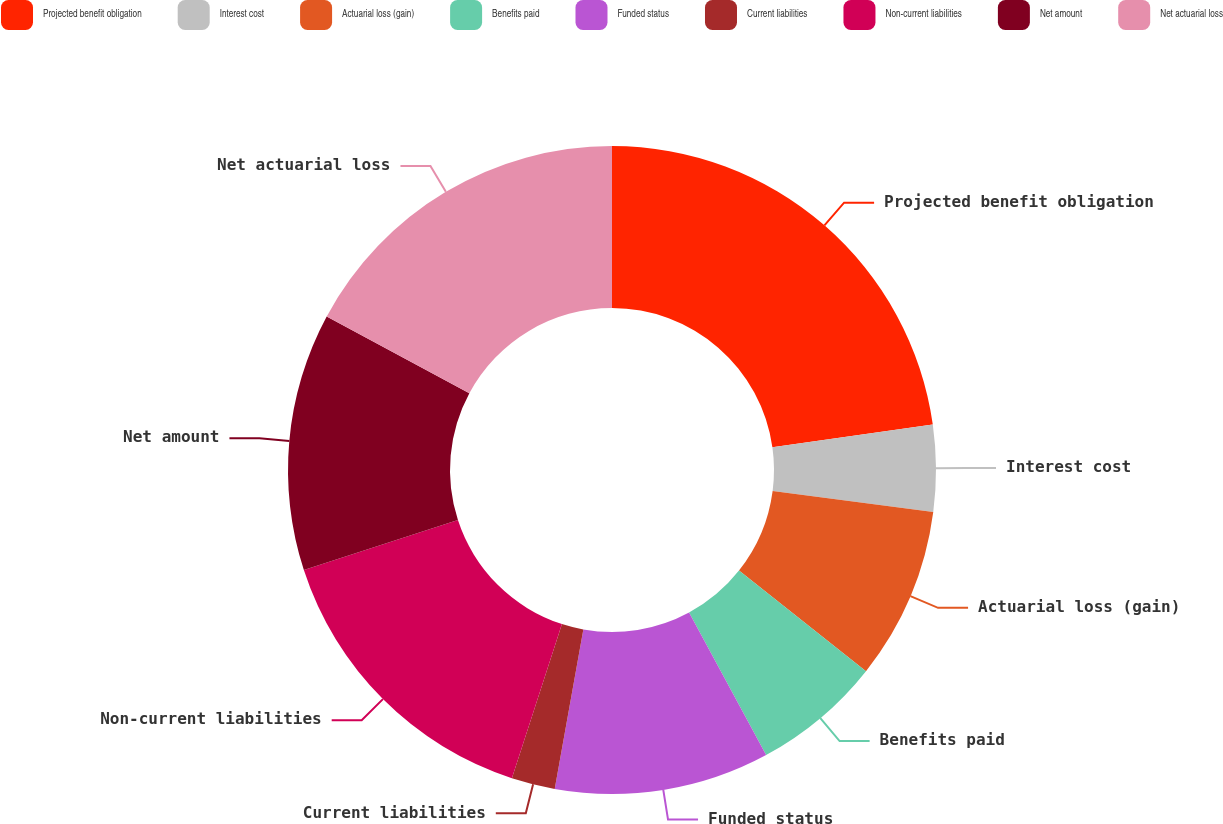<chart> <loc_0><loc_0><loc_500><loc_500><pie_chart><fcel>Projected benefit obligation<fcel>Interest cost<fcel>Actuarial loss (gain)<fcel>Benefits paid<fcel>Funded status<fcel>Current liabilities<fcel>Non-current liabilities<fcel>Net amount<fcel>Net actuarial loss<nl><fcel>22.76%<fcel>4.31%<fcel>8.59%<fcel>6.45%<fcel>10.72%<fcel>2.17%<fcel>15.0%<fcel>12.86%<fcel>17.14%<nl></chart> 